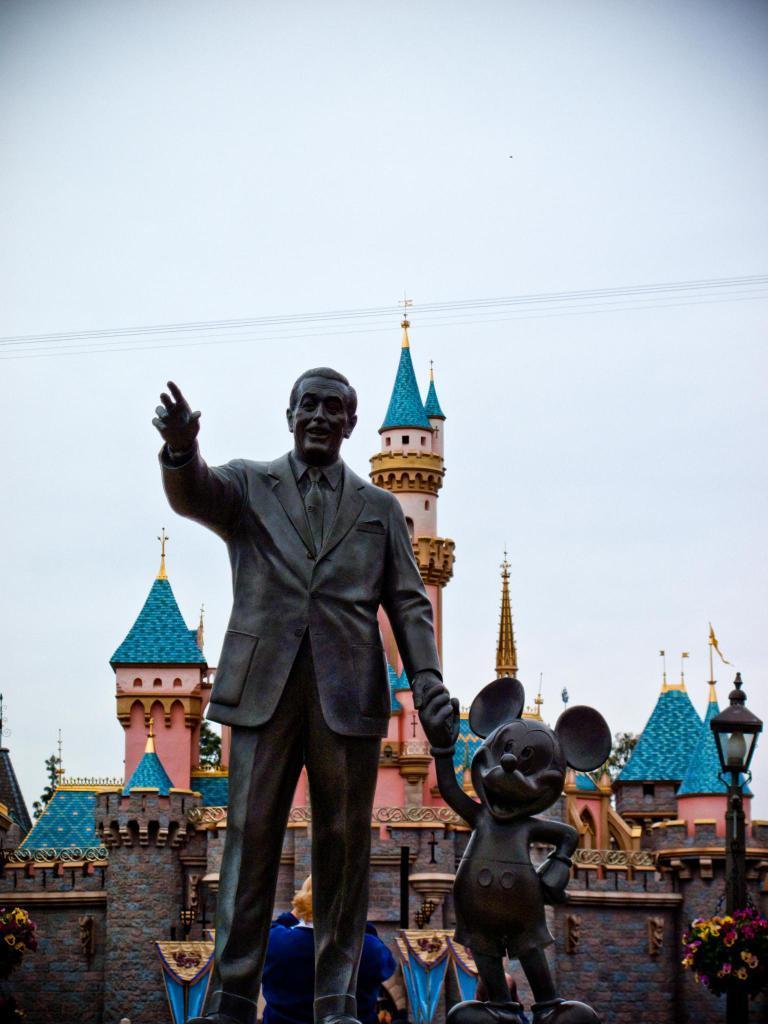Could you give a brief overview of what you see in this image? In the foreground of this image, there are two statues. In the background, there is a castle and a light pole on the right. At the top, there is the sky. 